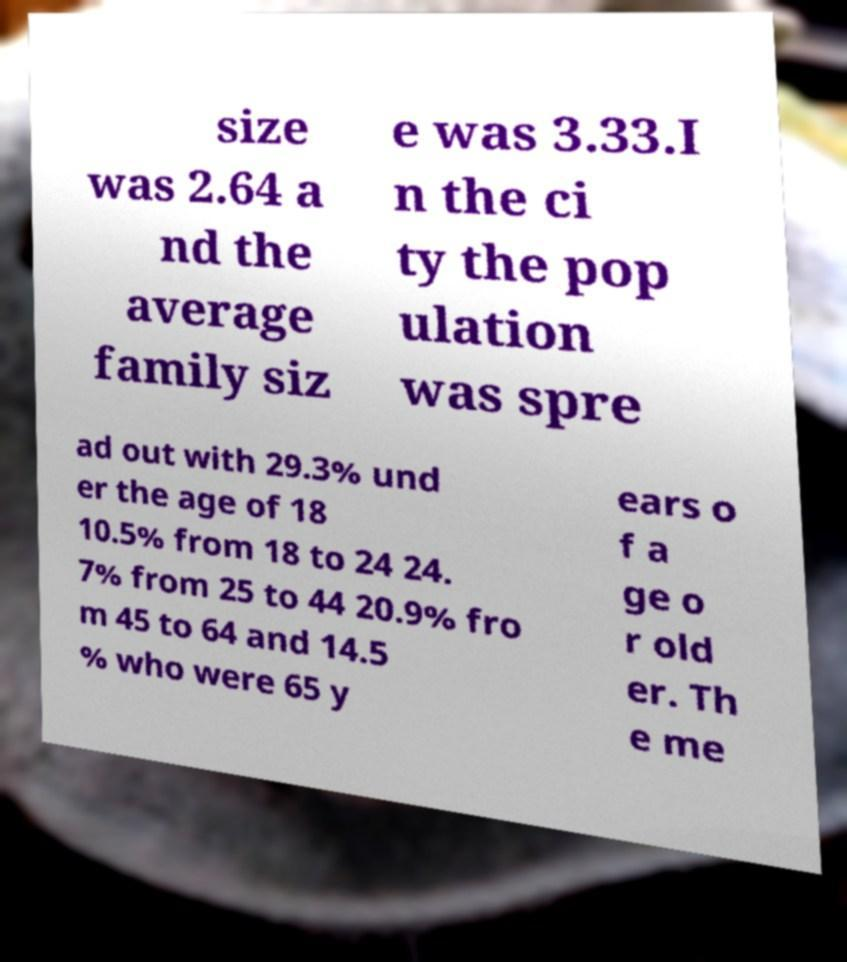What messages or text are displayed in this image? I need them in a readable, typed format. size was 2.64 a nd the average family siz e was 3.33.I n the ci ty the pop ulation was spre ad out with 29.3% und er the age of 18 10.5% from 18 to 24 24. 7% from 25 to 44 20.9% fro m 45 to 64 and 14.5 % who were 65 y ears o f a ge o r old er. Th e me 